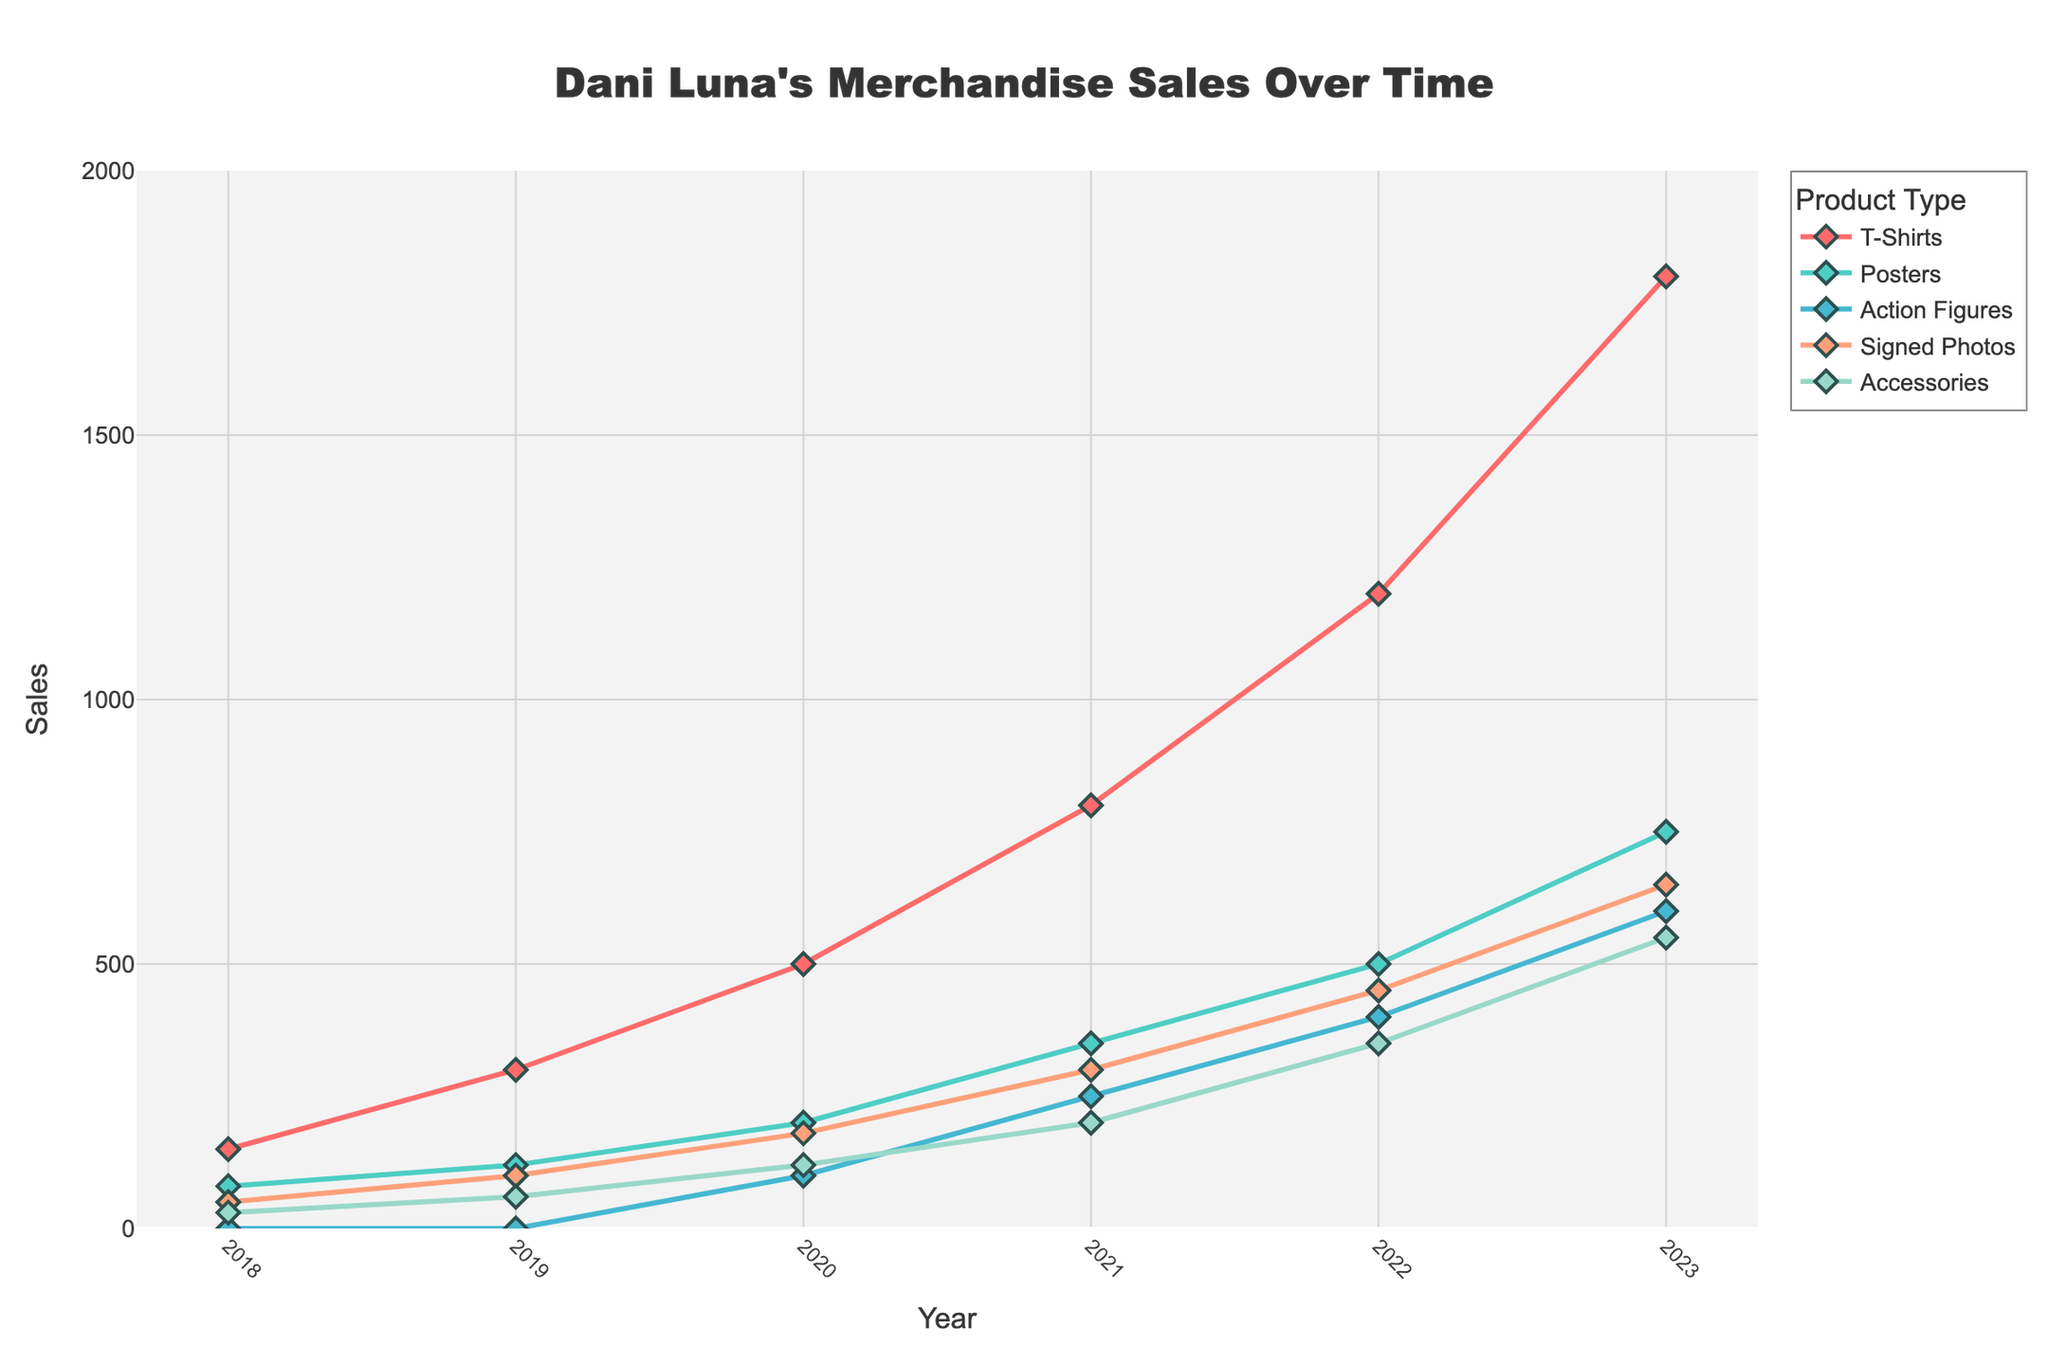Which product experienced the highest increase in sales from 2022 to 2023? To find the highest increase, we need to look at the difference in sales for each product from 2022 to 2023. By calculating the differences: T-Shirts (1800-1200=600), Posters (750-500=250), Action Figures (600-400=200), Signed Photos (650-450=200), and Accessories (550-350=200). The largest increase is 600 in T-Shirts.
Answer: T-Shirts Which years saw the biggest sales hike for Posters? To determine this, check the increase in sales for each year for Posters. The changes are: 2018 to 2019 (40), 2019 to 2020 (80), 2020 to 2021 (150), 2021 to 2022 (150), 2022 to 2023 (250). The largest increase is from 2022 to 2023 with 250.
Answer: 2022 to 2023 What is the total sales of Accessories over all the years? We need to sum up Accessories sales numbers from each year: 30 (2018) + 60 (2019) + 120 (2020) + 200 (2021) + 350 (2022) + 550 (2023). The total is 1310.
Answer: 1310 By how much did T-Shirts outsell Posters in 2023? To calculate this, subtract the sales of Posters from the sales of T-Shirts in 2023: 1800 (T-Shirts) - 750 (Posters) = 1050.
Answer: 1050 Which product had no sales in the initial years but started selling later? Looking at the data, Action Figures had 0 sales in 2018 and 2019, but started selling in 2020 with 100 units.
Answer: Action Figures In which year did Signed Photos sales triple compared to its previous year? Checking the year-over-year sales for Signed Photos: 50 (2018), 100 (2019), 180 (2020), 300 (2021), 450 (2022), 650 (2023). Reviewing the data shows that from 2019 (100) to 2020 (180) there is not a tripling, but from 2018 (50) to 2019 (100), sales doubled, and from 2020 to 2021 it nearly tripled (180 to 300 but not quite 180*3). For actual tripling, none met exactly 3 times the sales of the previous year.
Answer: None How many different product types surpassed the 500 sales mark by 2023? Checking each product's sales in 2023: T-Shirts (1800), Posters (750), Action Figures (600), Signed Photos (650), and Accessories (550). All five products surpassed the 500 sales mark.
Answer: 5 What trend do you observe in the sales of Signed Photos from 2018 to 2023? Signed Photos show a continuous increase every year from 2018 to 2023: 50, 100, 180, 300, 450, 650. This indicates a steady upward trend.
Answer: Continuous increase Which product had the least sales in 2020 and by how much? In 2020, the sales for each product are: T-Shirts (500), Posters (200), Action Figures (100), Signed Photos (180), Accessories (120). Action Figures had the least sales with 100 units.
Answer: Action Figures, 100 